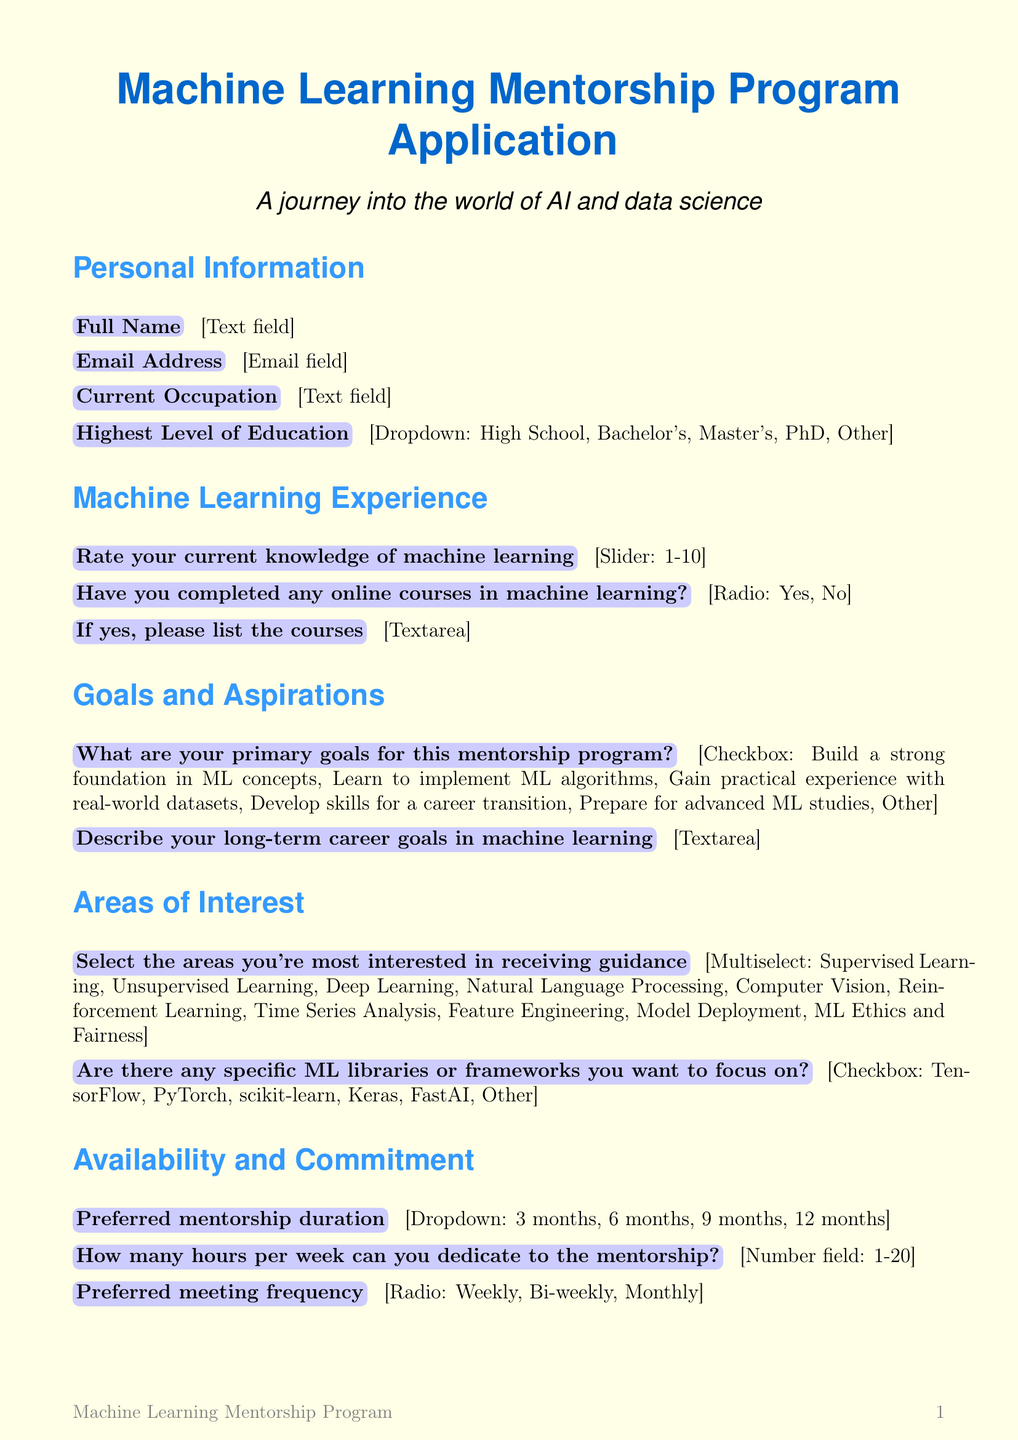what is the title of the document? The title is presented in a prominent manner at the top of the document.
Answer: Machine Learning Mentorship Program Application how many options are available for the highest level of education? The document lists different educational levels in a dropdown format.
Answer: Five what is the required rating scale for current knowledge of machine learning? The document specifies the range of the slider for assessing knowledge.
Answer: One to ten what is the maximum number of hours per week one can dedicate to mentorship? The document indicates a limit on weekly commitment for mentorship hours.
Answer: Twenty what are the preferred mentorship durations listed in the document? The document presents multiple time duration options in a dropdown menu.
Answer: Three months, six months, nine months, twelve months what is one of the primary goals listed for the mentorship program? The document provides a checklist of various goals participants can choose from.
Answer: Build a strong foundation in ML concepts how many meeting frequency options are available in the application? The document outlines different potential meeting frequencies.
Answer: Three is there an option to indicate ongoing ML projects? The document includes a specific question addressing ongoing projects for participants.
Answer: Yes does the application require an understanding of commitment? The document includes a section focusing on the expectations of participation.
Answer: Yes 